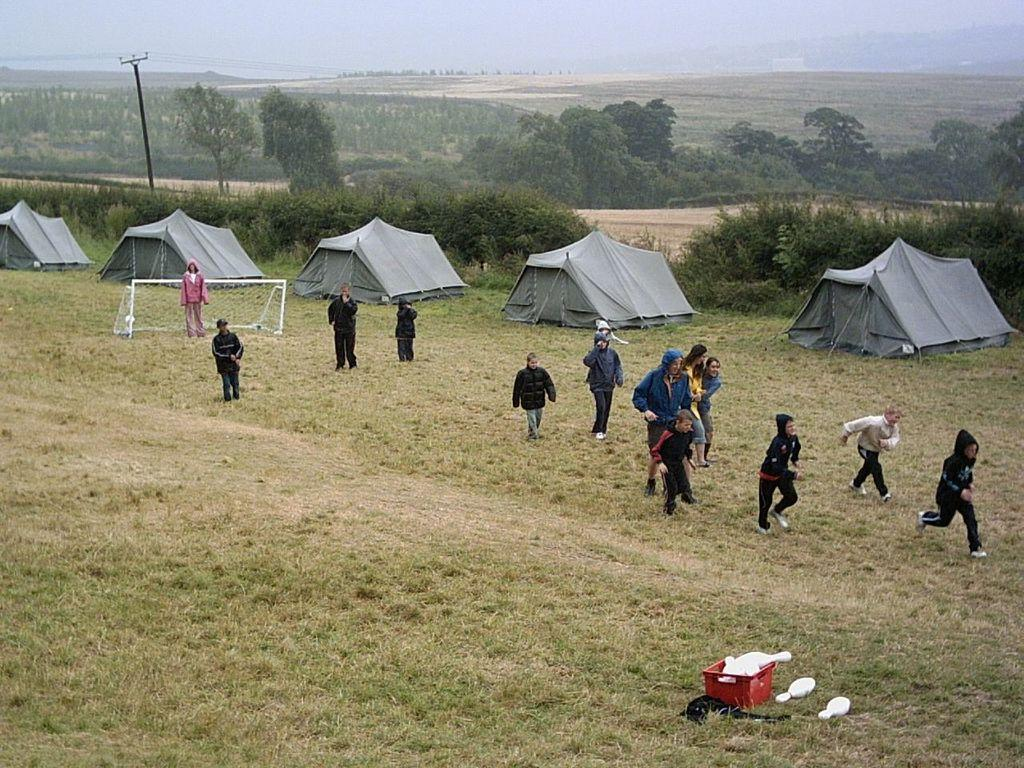What is the main subject of the image? The main subject of the image is a group of people. Can you describe the setting in which the people are located? The people are in the middle of tent houses. What can be seen in the background of the image? The sky is visible in the background of the image. Are there any fairies flying around the tent houses in the image? There is no mention of fairies in the image, so we cannot confirm their presence. 